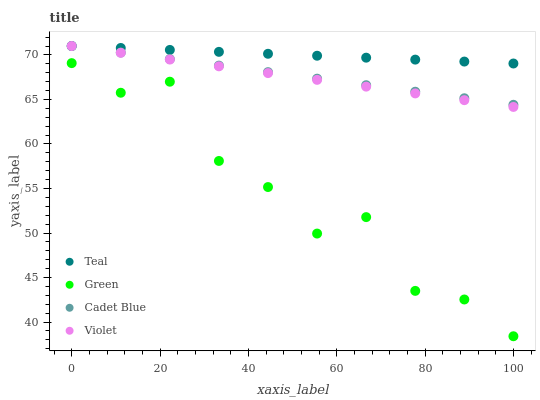Does Green have the minimum area under the curve?
Answer yes or no. Yes. Does Teal have the maximum area under the curve?
Answer yes or no. Yes. Does Teal have the minimum area under the curve?
Answer yes or no. No. Does Green have the maximum area under the curve?
Answer yes or no. No. Is Violet the smoothest?
Answer yes or no. Yes. Is Green the roughest?
Answer yes or no. Yes. Is Teal the smoothest?
Answer yes or no. No. Is Teal the roughest?
Answer yes or no. No. Does Green have the lowest value?
Answer yes or no. Yes. Does Teal have the lowest value?
Answer yes or no. No. Does Violet have the highest value?
Answer yes or no. Yes. Does Green have the highest value?
Answer yes or no. No. Is Green less than Cadet Blue?
Answer yes or no. Yes. Is Teal greater than Green?
Answer yes or no. Yes. Does Cadet Blue intersect Violet?
Answer yes or no. Yes. Is Cadet Blue less than Violet?
Answer yes or no. No. Is Cadet Blue greater than Violet?
Answer yes or no. No. Does Green intersect Cadet Blue?
Answer yes or no. No. 